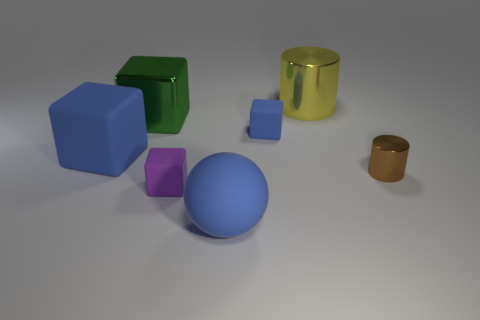The metal object in front of the blue matte object that is on the left side of the tiny purple rubber block is what color?
Offer a very short reply. Brown. How many objects are either tiny purple matte objects that are in front of the large blue rubber block or brown metallic cylinders?
Offer a very short reply. 2. Is the size of the yellow cylinder the same as the matte thing that is to the right of the matte sphere?
Give a very brief answer. No. What number of large objects are blue matte spheres or yellow cylinders?
Ensure brevity in your answer.  2. What is the shape of the yellow metallic object?
Provide a short and direct response. Cylinder. There is another cube that is the same color as the large rubber block; what size is it?
Give a very brief answer. Small. Are there any other small objects that have the same material as the brown object?
Give a very brief answer. No. Are there more big yellow metal things than large cyan cylinders?
Keep it short and to the point. Yes. Is the ball made of the same material as the large blue cube?
Make the answer very short. Yes. What number of rubber things are either red cubes or tiny cylinders?
Give a very brief answer. 0. 